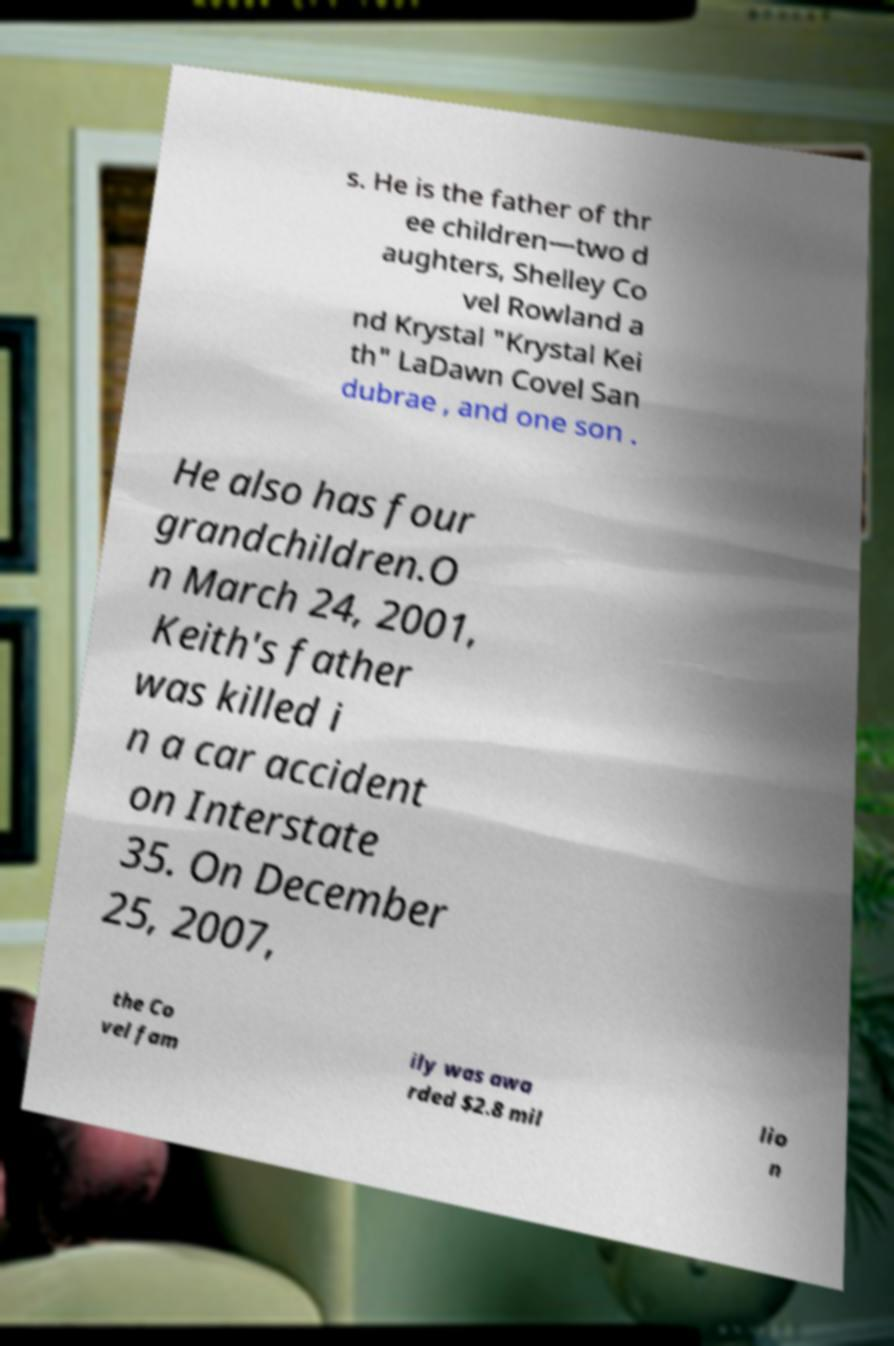What messages or text are displayed in this image? I need them in a readable, typed format. s. He is the father of thr ee children—two d aughters, Shelley Co vel Rowland a nd Krystal "Krystal Kei th" LaDawn Covel San dubrae , and one son . He also has four grandchildren.O n March 24, 2001, Keith's father was killed i n a car accident on Interstate 35. On December 25, 2007, the Co vel fam ily was awa rded $2.8 mil lio n 